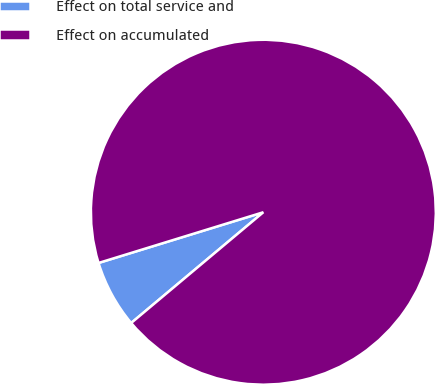Convert chart to OTSL. <chart><loc_0><loc_0><loc_500><loc_500><pie_chart><fcel>Effect on total service and<fcel>Effect on accumulated<nl><fcel>6.35%<fcel>93.65%<nl></chart> 